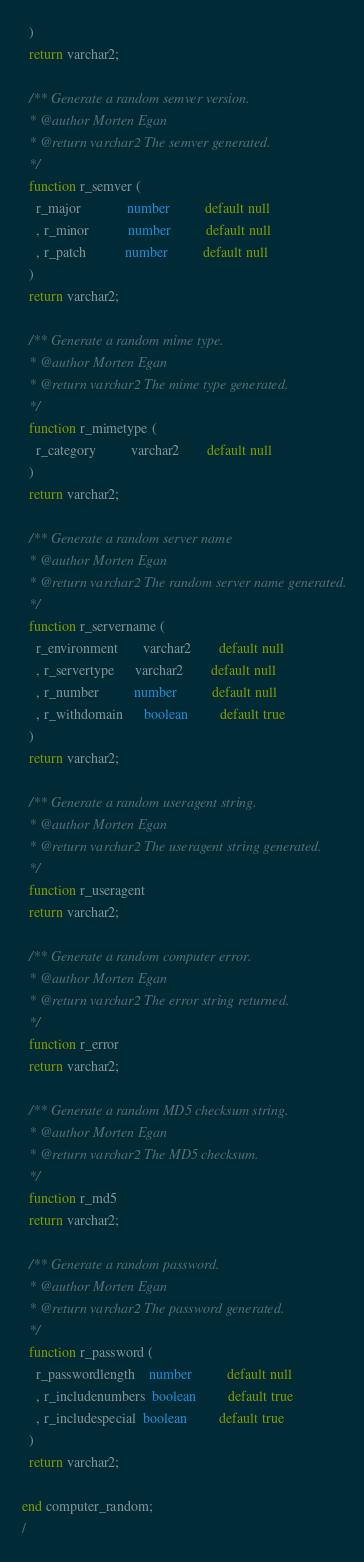<code> <loc_0><loc_0><loc_500><loc_500><_SQL_>  )
  return varchar2;

  /** Generate a random semver version.
  * @author Morten Egan
  * @return varchar2 The semver generated.
  */
  function r_semver (
    r_major             number          default null
    , r_minor           number          default null
    , r_patch           number          default null
  )
  return varchar2;

  /** Generate a random mime type.
  * @author Morten Egan
  * @return varchar2 The mime type generated.
  */
  function r_mimetype (
    r_category          varchar2        default null
  )
  return varchar2;

  /** Generate a random server name
  * @author Morten Egan
  * @return varchar2 The random server name generated.
  */
  function r_servername (
    r_environment       varchar2        default null
    , r_servertype      varchar2        default null
    , r_number          number          default null
    , r_withdomain      boolean         default true
  )
  return varchar2;

  /** Generate a random useragent string.
  * @author Morten Egan
  * @return varchar2 The useragent string generated.
  */
  function r_useragent
  return varchar2;

  /** Generate a random computer error.
  * @author Morten Egan
  * @return varchar2 The error string returned.
  */
  function r_error
  return varchar2;

  /** Generate a random MD5 checksum string.
  * @author Morten Egan
  * @return varchar2 The MD5 checksum.
  */
  function r_md5
  return varchar2;

  /** Generate a random password.
  * @author Morten Egan
  * @return varchar2 The password generated.
  */
  function r_password (
    r_passwordlength    number          default null
    , r_includenumbers  boolean         default true
    , r_includespecial  boolean         default true
  )
  return varchar2;

end computer_random;
/
</code> 